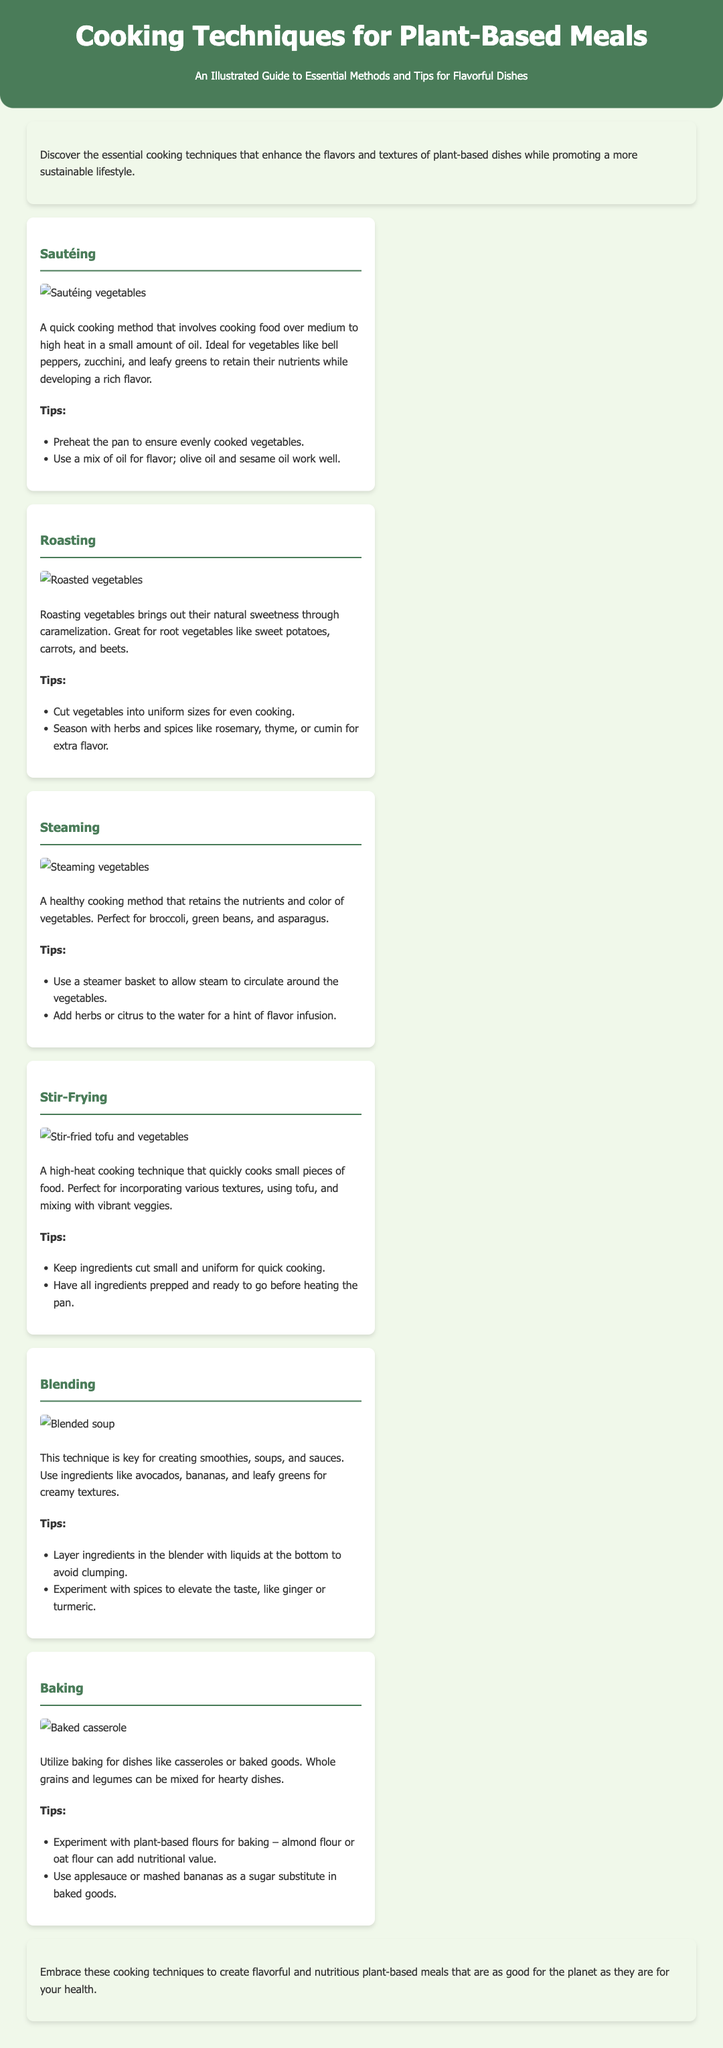What is the title of the document? The title of the document is indicated at the top of the page as the main heading.
Answer: Cooking Techniques for Plant-Based Meals What cooking technique enhances the sweetness of vegetables? The technique that enhances the sweetness of vegetables through caramelization is mentioned in relation to a specific method in the document.
Answer: Roasting Which method is described as ideal for broccoli, green beans, and asparagus? The text clearly specifies the method that is perfect for retaining the nutrients and color of these vegetables.
Answer: Steaming What should you add to the water for flavor infusion while steaming? The document highlights a suggestion for an element to add for enhancing flavor during steaming.
Answer: Herbs or citrus What is the ideal condition for sautéing vegetables? The document states the temperature range to cook food while sautéing so that nutrients are retained.
Answer: Medium to high heat Which cooking method requires ingredients to be cut small and uniform? The document indicates a specific technique requiring the size of the ingredients to ensure quick cooking.
Answer: Stir-Frying Which ingredient is suggested as a sugar substitute in baked goods? The document provides an alternative to sugar for baking, specifically mentioning a fruit that can be used.
Answer: Applesauce or mashed bananas What type of dishes can be made using baking? The text outlines the kind of dishes that can be prepared using the baking method, indicating a specific category.
Answer: Casseroles or baked goods 